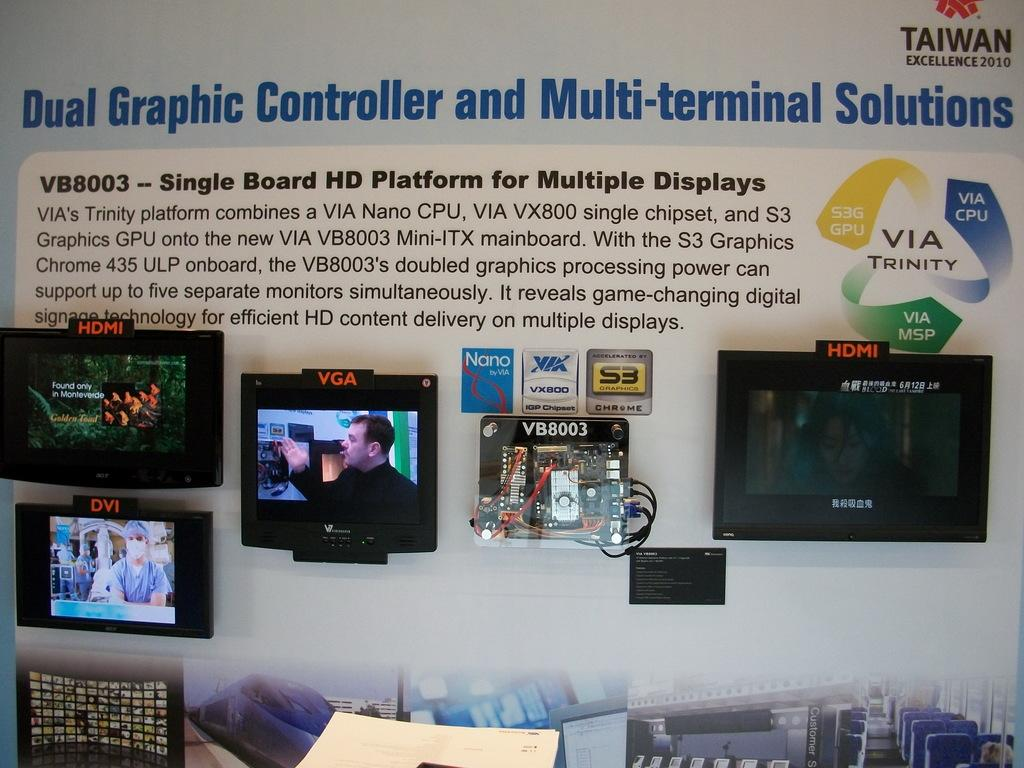<image>
Create a compact narrative representing the image presented. A display of screens says Taiwan Excellence 2010 at the top. 